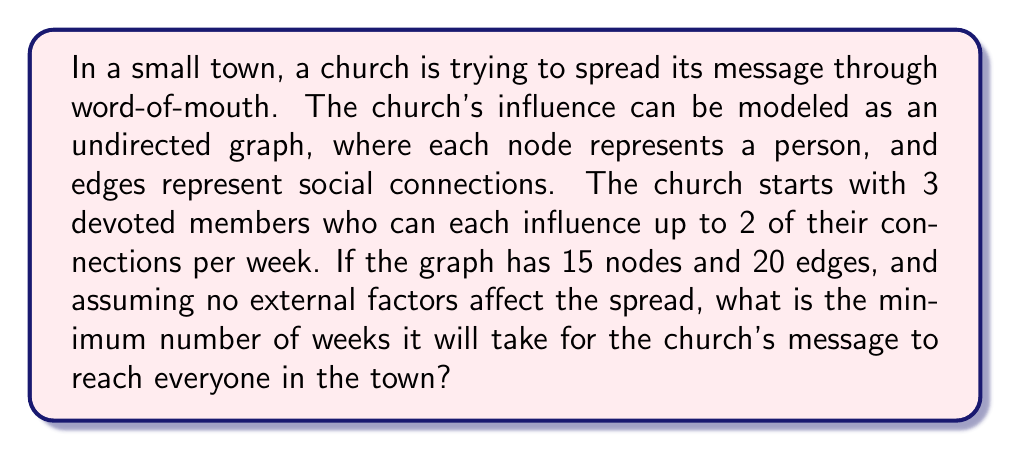Help me with this question. Let's approach this step-by-step:

1) First, we need to understand the initial conditions:
   - Total population (nodes): 15
   - Initial devoted members: 3
   - Each member can influence up to 2 connections per week

2) Let's model the spread:
   Week 0: 3 devoted members
   Week 1: Each of the 3 can influence 2 more, so potentially 6 new members
           3 + 6 = 9 total
   Week 2: The 6 new members can each influence 2 more, so potentially 12 new members
           9 + 12 = 21 total (but we only have 15 people)

3) We can represent this mathematically:
   Let $a_n$ be the number of people influenced after $n$ weeks.
   $a_0 = 3$
   $a_1 = \min(3 + 3 \cdot 2, 15) = 9$
   $a_2 = \min(9 + 6 \cdot 2, 15) = 15$

4) We see that by the end of Week 2, all 15 people would be reached.

5) It's important to note that this is the minimum number of weeks. In reality, the spread might be slower due to:
   - The graph structure (some people might be less connected)
   - Not all connections being equally receptive to the message

However, given the constraints of the problem and assuming optimal conditions, 2 weeks is the minimum time required.
Answer: 2 weeks 